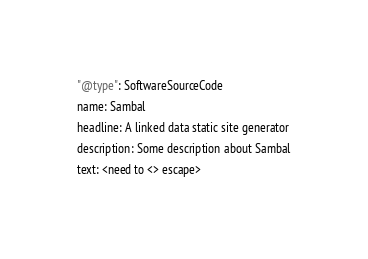Convert code to text. <code><loc_0><loc_0><loc_500><loc_500><_YAML_>"@type": SoftwareSourceCode
name: Sambal
headline: A linked data static site generator
description: Some description about Sambal
text: <need to <> escape></code> 